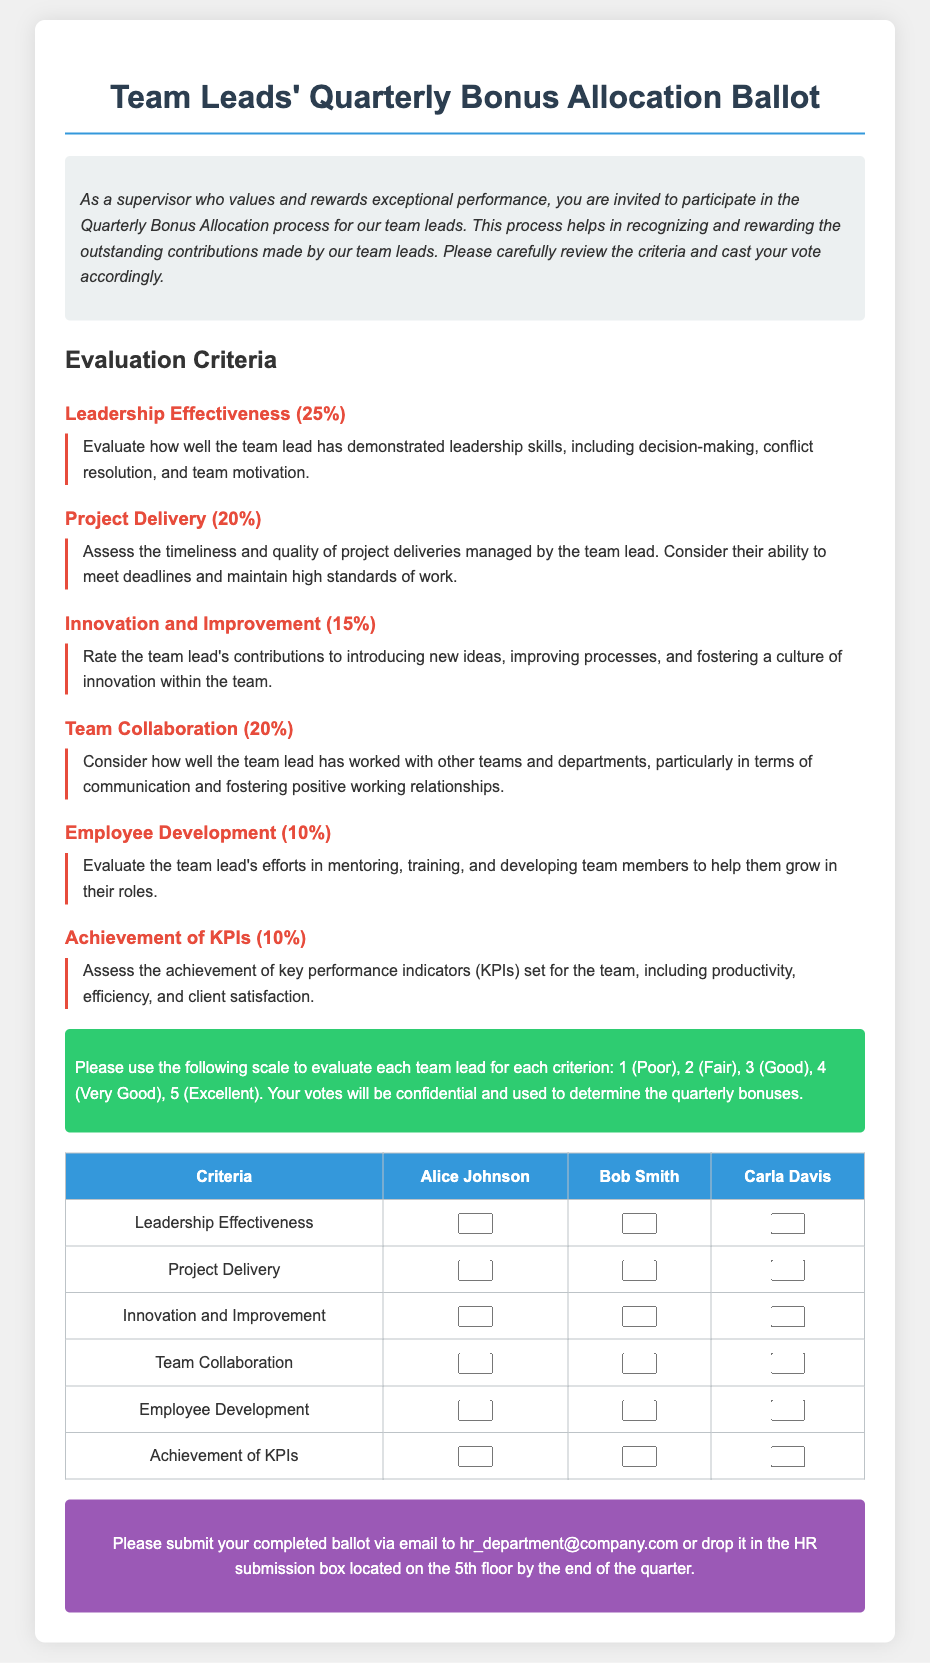What is the title of the document? The title is prominently displayed at the top of the document.
Answer: Team Leads' Quarterly Bonus Allocation Ballot What is the maximum score for each criterion? The document specifies a scoring scale where 5 is the highest score for each criterion.
Answer: 5 How many criteria are there for evaluation? The document lists six distinct criteria for evaluation.
Answer: 6 What percentage is allocated to Leadership Effectiveness? The document states the percentage for each criterion, specifically for Leadership Effectiveness.
Answer: 25% Who are the team leads being evaluated? The table includes the names of the team leads for which evaluations are being made.
Answer: Alice Johnson, Bob Smith, Carla Davis What is the email address for ballot submission? The document provides a specific email address for submitting the completed ballot.
Answer: hr_department@company.com Which criterion has the lowest percentage weight? The percentages are listed for each criterion, indicating which has the lowest.
Answer: Employee Development What is the criterion for assessing team collaboration? The document describes a specific evaluation criterion dedicated to team collaboration.
Answer: Team Collaboration What is the deadline for submitting the ballot? The document specifies when the completed ballot should be submitted.
Answer: By the end of the quarter 